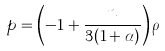<formula> <loc_0><loc_0><loc_500><loc_500>p = \left ( - 1 + \frac { n } { 3 ( 1 + \alpha ) } \right ) \rho</formula> 